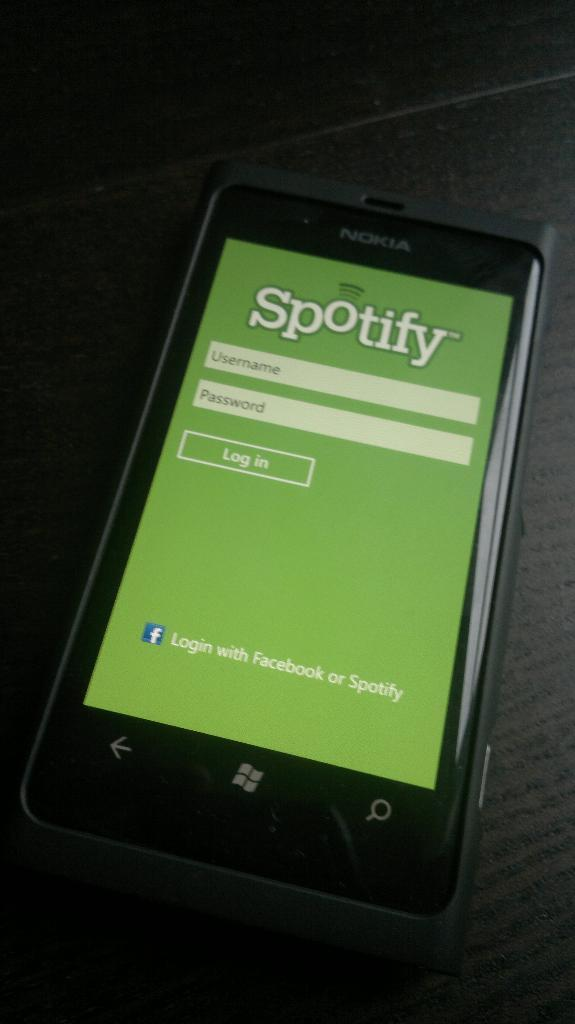<image>
Write a terse but informative summary of the picture. a microsoft cell phone open to a spotify login page 